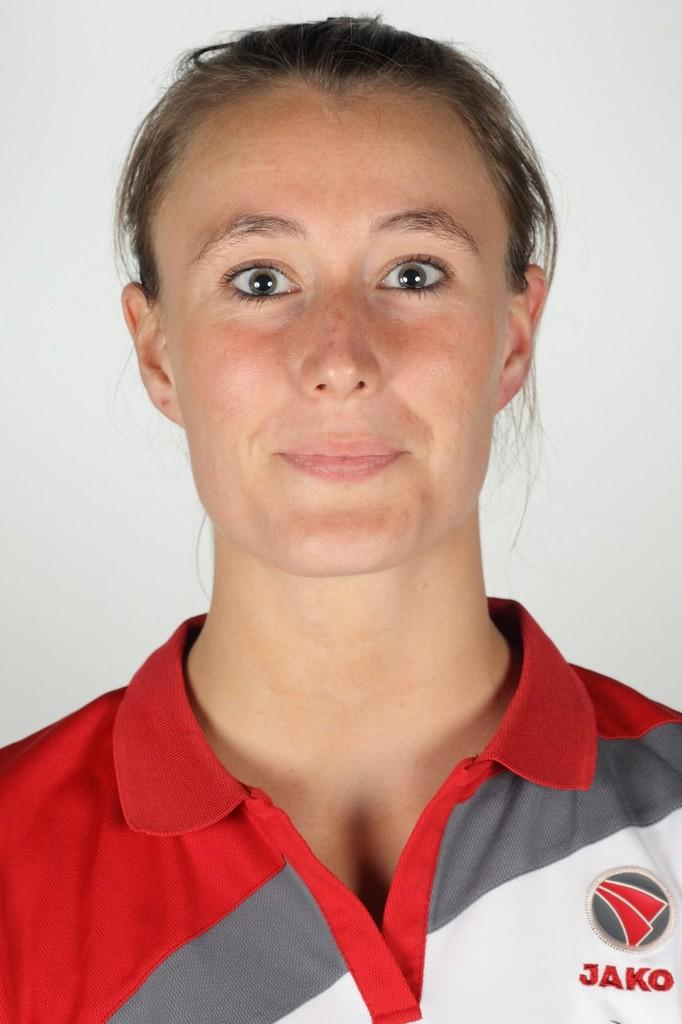<image>
Provide a brief description of the given image. A woman wearing a collared shirt that says JAKO poses for the camera. 